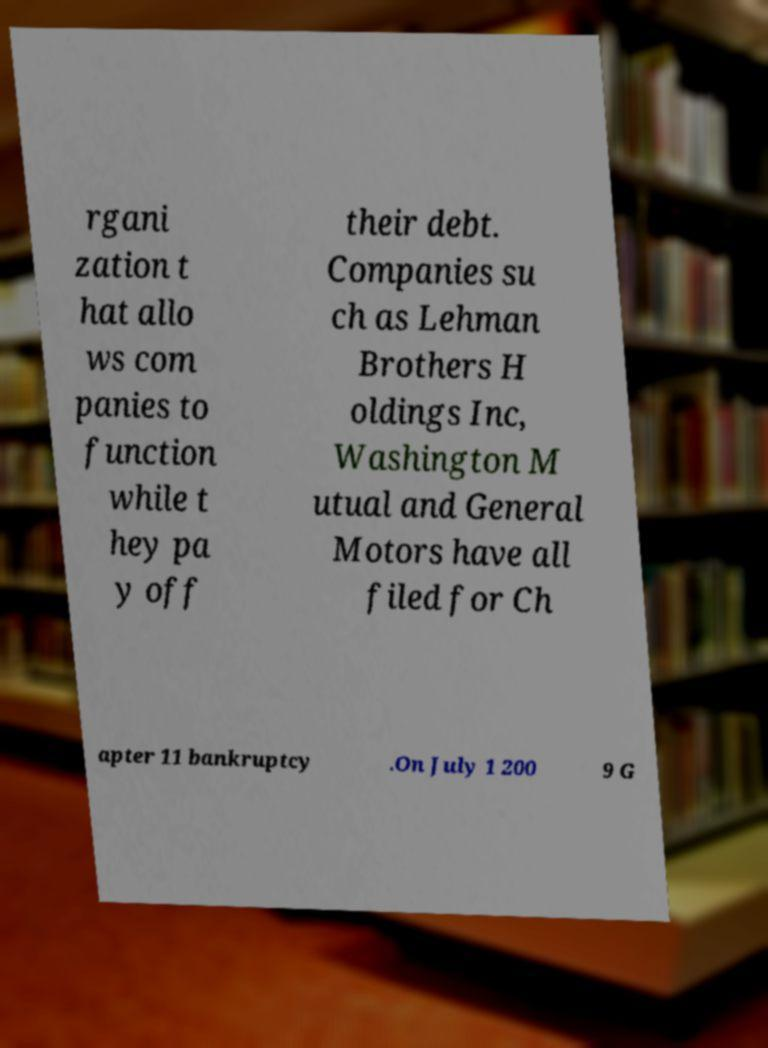Can you read and provide the text displayed in the image?This photo seems to have some interesting text. Can you extract and type it out for me? rgani zation t hat allo ws com panies to function while t hey pa y off their debt. Companies su ch as Lehman Brothers H oldings Inc, Washington M utual and General Motors have all filed for Ch apter 11 bankruptcy .On July 1 200 9 G 